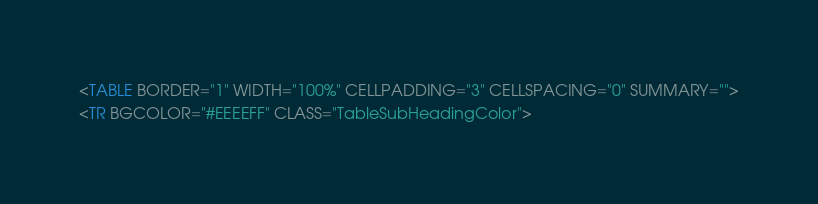<code> <loc_0><loc_0><loc_500><loc_500><_HTML_><TABLE BORDER="1" WIDTH="100%" CELLPADDING="3" CELLSPACING="0" SUMMARY="">
<TR BGCOLOR="#EEEEFF" CLASS="TableSubHeadingColor"></code> 